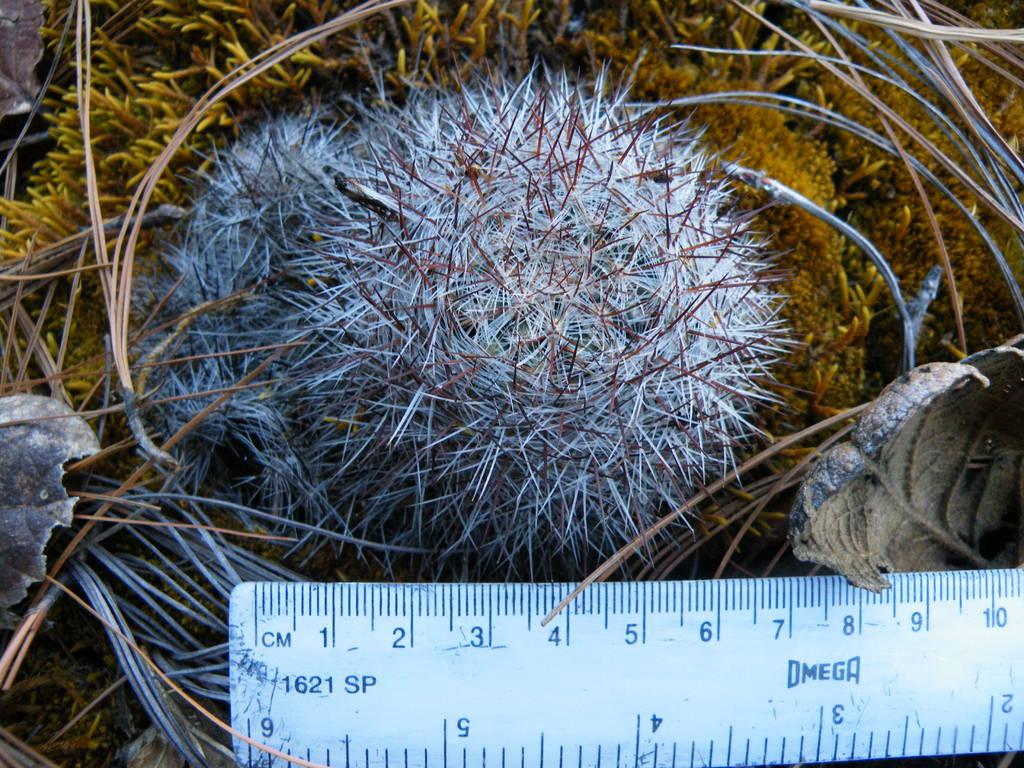What units are the ruler in?
Make the answer very short. Cm. What is the left number on the ruler?
Offer a very short reply. 1. 